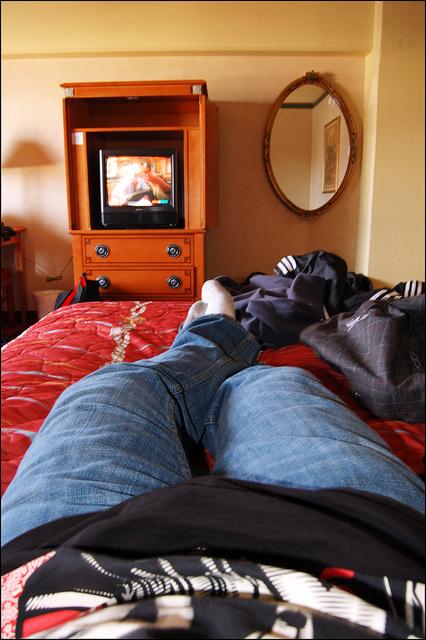Is the person on the bed fully dressed?
Quick response, please. Yes. Is this person laying down?
Keep it brief. Yes. Why is there a shadow on the wall?
Quick response, please. Lamp. 